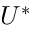<formula> <loc_0><loc_0><loc_500><loc_500>U ^ { * }</formula> 